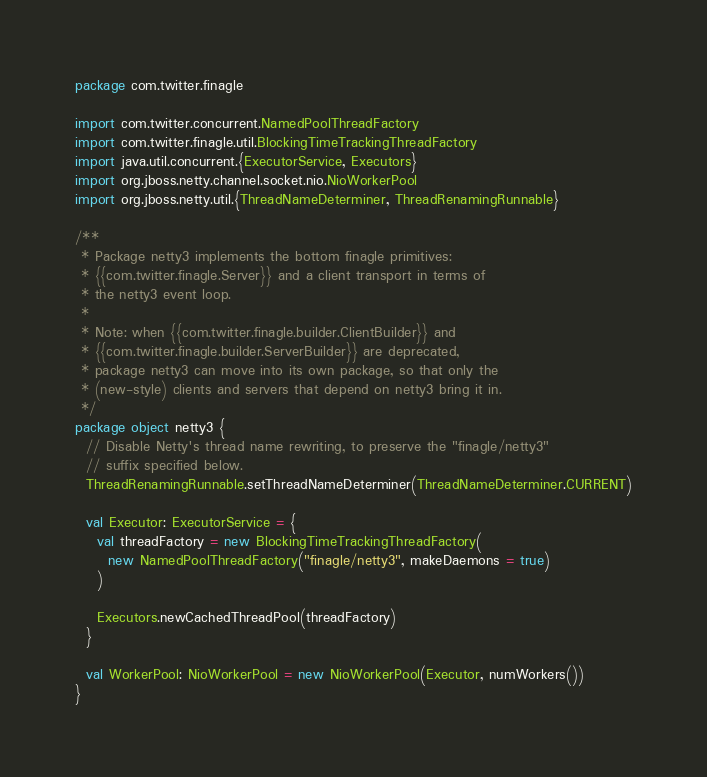Convert code to text. <code><loc_0><loc_0><loc_500><loc_500><_Scala_>package com.twitter.finagle

import com.twitter.concurrent.NamedPoolThreadFactory
import com.twitter.finagle.util.BlockingTimeTrackingThreadFactory
import java.util.concurrent.{ExecutorService, Executors}
import org.jboss.netty.channel.socket.nio.NioWorkerPool
import org.jboss.netty.util.{ThreadNameDeterminer, ThreadRenamingRunnable}

/**
 * Package netty3 implements the bottom finagle primitives:
 * {{com.twitter.finagle.Server}} and a client transport in terms of
 * the netty3 event loop.
 *
 * Note: when {{com.twitter.finagle.builder.ClientBuilder}} and
 * {{com.twitter.finagle.builder.ServerBuilder}} are deprecated,
 * package netty3 can move into its own package, so that only the
 * (new-style) clients and servers that depend on netty3 bring it in.
 */
package object netty3 {
  // Disable Netty's thread name rewriting, to preserve the "finagle/netty3"
  // suffix specified below.
  ThreadRenamingRunnable.setThreadNameDeterminer(ThreadNameDeterminer.CURRENT)

  val Executor: ExecutorService = {
    val threadFactory = new BlockingTimeTrackingThreadFactory(
      new NamedPoolThreadFactory("finagle/netty3", makeDaemons = true)
    )

    Executors.newCachedThreadPool(threadFactory)
  }

  val WorkerPool: NioWorkerPool = new NioWorkerPool(Executor, numWorkers())
}
</code> 